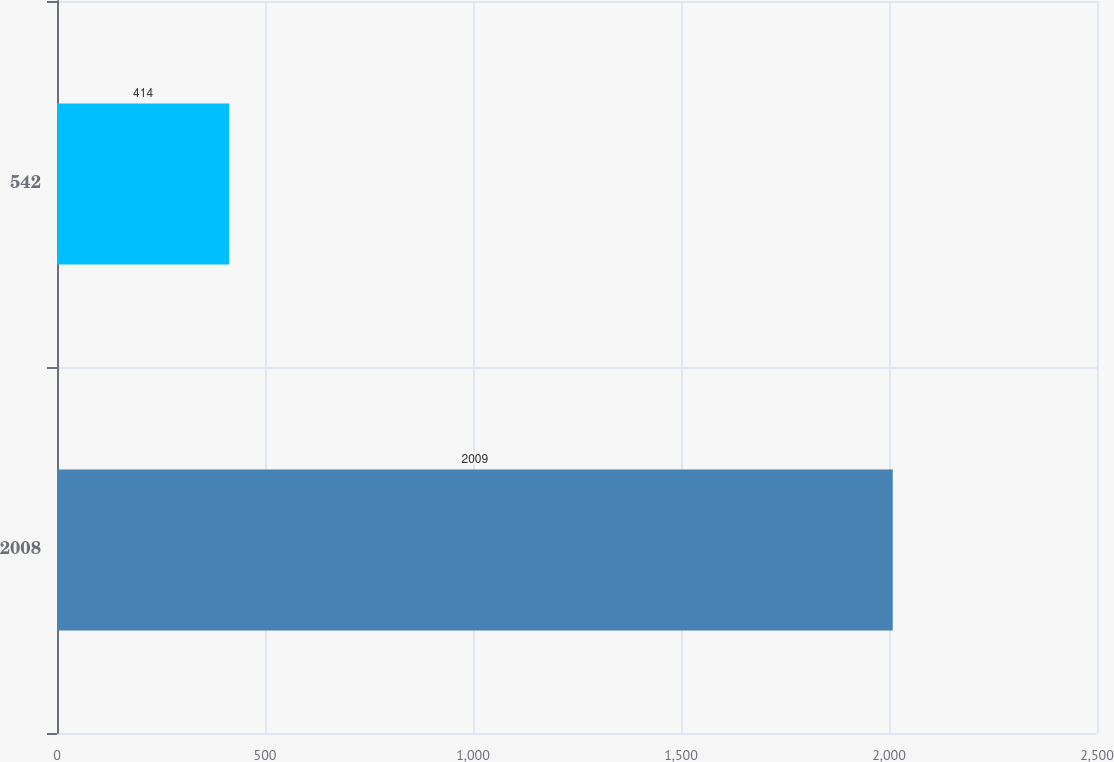<chart> <loc_0><loc_0><loc_500><loc_500><bar_chart><fcel>2008<fcel>542<nl><fcel>2009<fcel>414<nl></chart> 